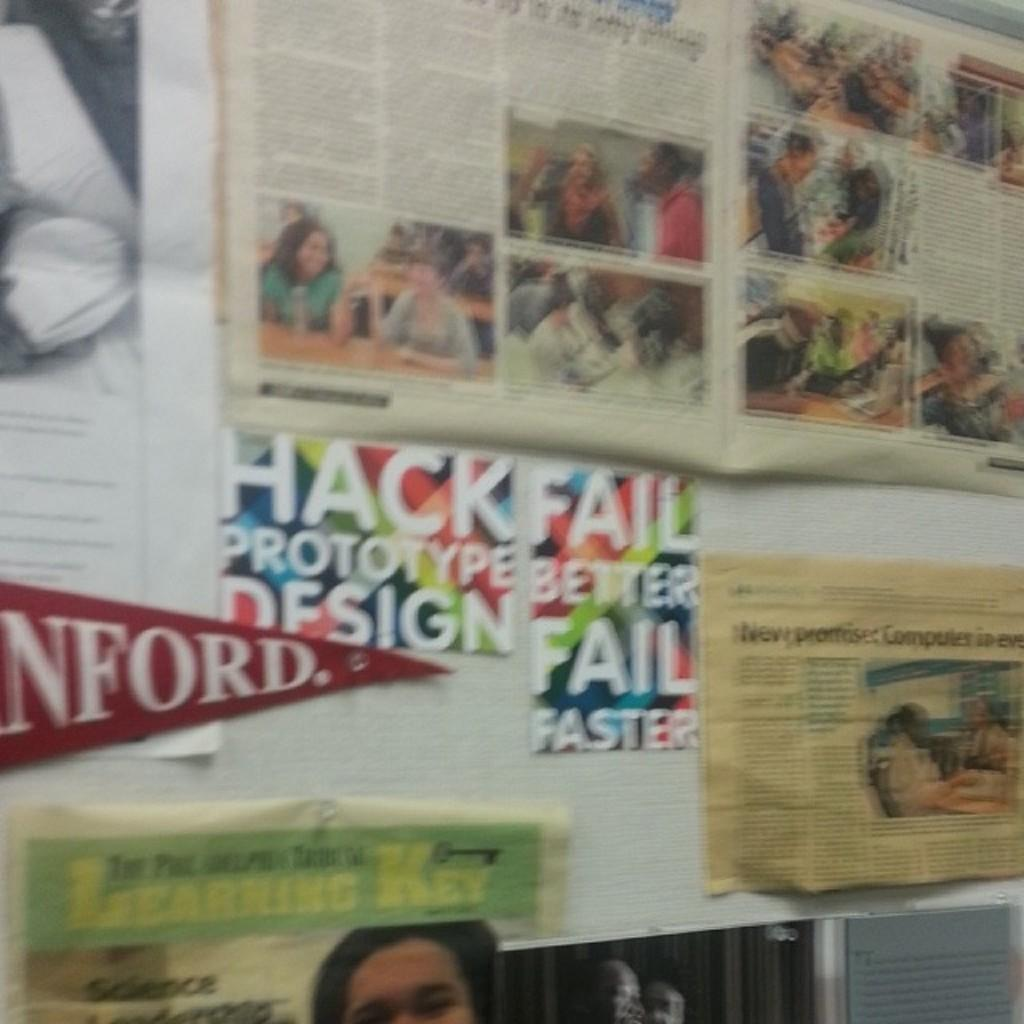<image>
Create a compact narrative representing the image presented. A sign with a colorful background reads hack fail. 